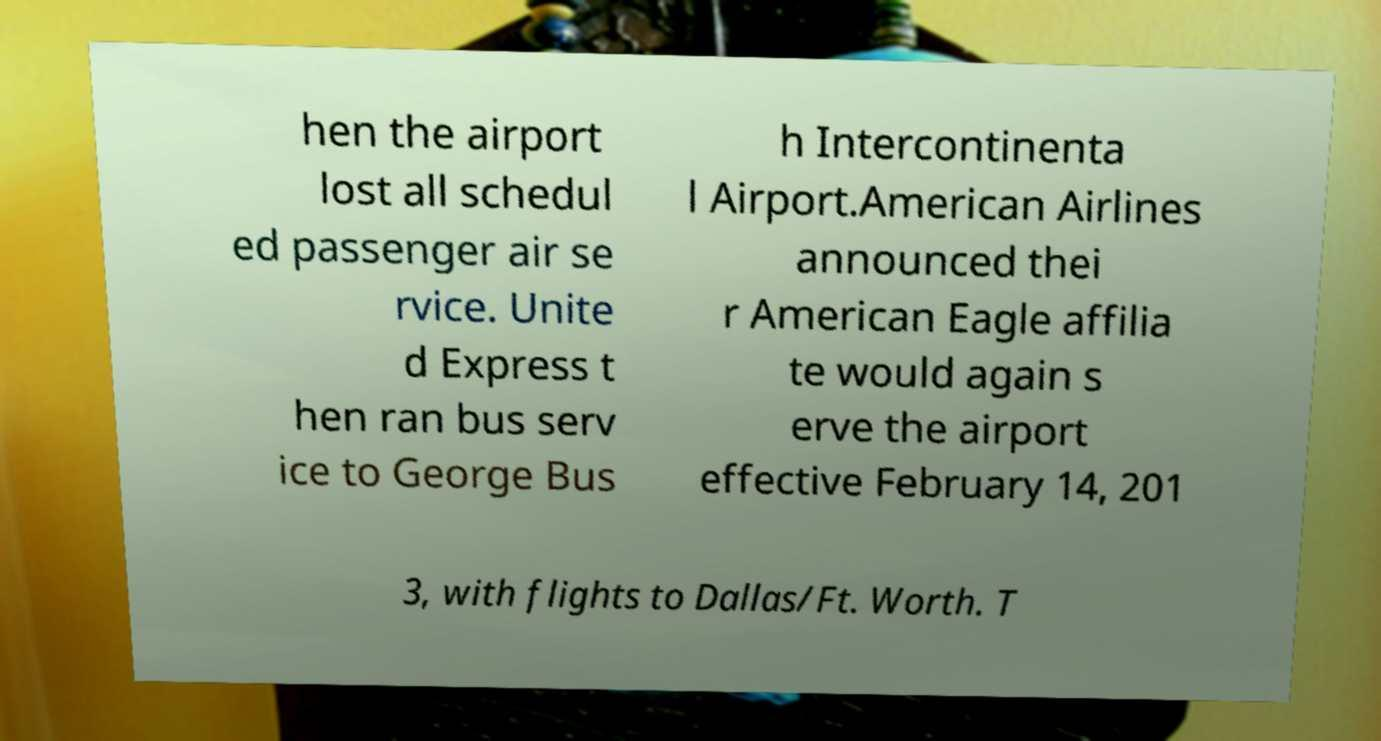Could you extract and type out the text from this image? hen the airport lost all schedul ed passenger air se rvice. Unite d Express t hen ran bus serv ice to George Bus h Intercontinenta l Airport.American Airlines announced thei r American Eagle affilia te would again s erve the airport effective February 14, 201 3, with flights to Dallas/Ft. Worth. T 